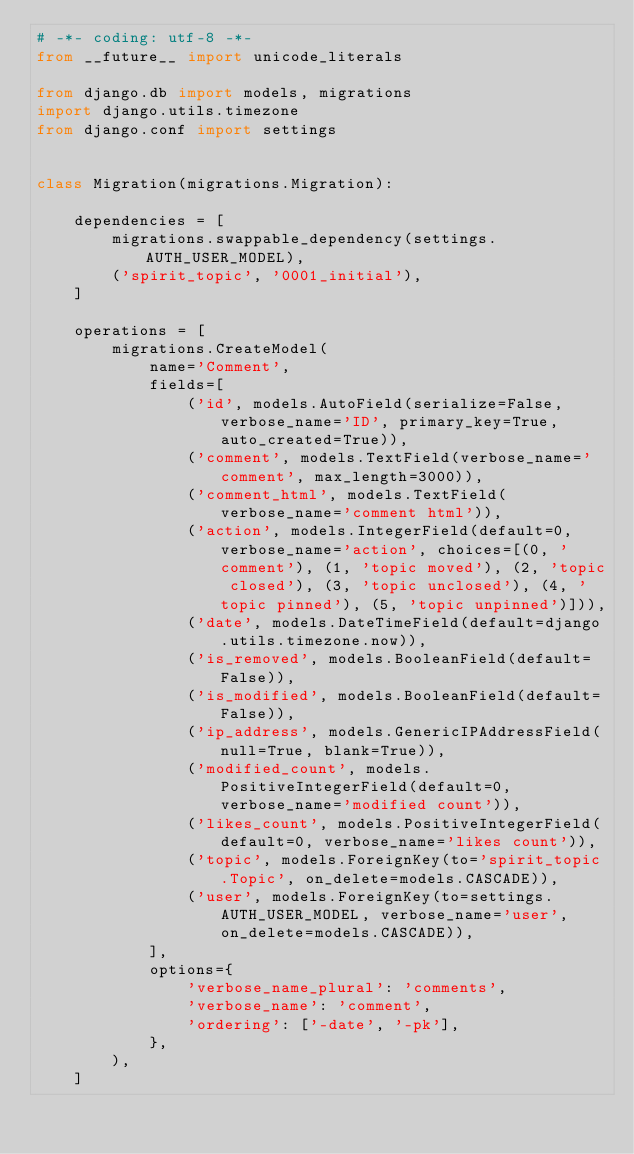Convert code to text. <code><loc_0><loc_0><loc_500><loc_500><_Python_># -*- coding: utf-8 -*-
from __future__ import unicode_literals

from django.db import models, migrations
import django.utils.timezone
from django.conf import settings


class Migration(migrations.Migration):

    dependencies = [
        migrations.swappable_dependency(settings.AUTH_USER_MODEL),
        ('spirit_topic', '0001_initial'),
    ]

    operations = [
        migrations.CreateModel(
            name='Comment',
            fields=[
                ('id', models.AutoField(serialize=False, verbose_name='ID', primary_key=True, auto_created=True)),
                ('comment', models.TextField(verbose_name='comment', max_length=3000)),
                ('comment_html', models.TextField(verbose_name='comment html')),
                ('action', models.IntegerField(default=0, verbose_name='action', choices=[(0, 'comment'), (1, 'topic moved'), (2, 'topic closed'), (3, 'topic unclosed'), (4, 'topic pinned'), (5, 'topic unpinned')])),
                ('date', models.DateTimeField(default=django.utils.timezone.now)),
                ('is_removed', models.BooleanField(default=False)),
                ('is_modified', models.BooleanField(default=False)),
                ('ip_address', models.GenericIPAddressField(null=True, blank=True)),
                ('modified_count', models.PositiveIntegerField(default=0, verbose_name='modified count')),
                ('likes_count', models.PositiveIntegerField(default=0, verbose_name='likes count')),
                ('topic', models.ForeignKey(to='spirit_topic.Topic', on_delete=models.CASCADE)),
                ('user', models.ForeignKey(to=settings.AUTH_USER_MODEL, verbose_name='user', on_delete=models.CASCADE)),
            ],
            options={
                'verbose_name_plural': 'comments',
                'verbose_name': 'comment',
                'ordering': ['-date', '-pk'],
            },
        ),
    ]
</code> 